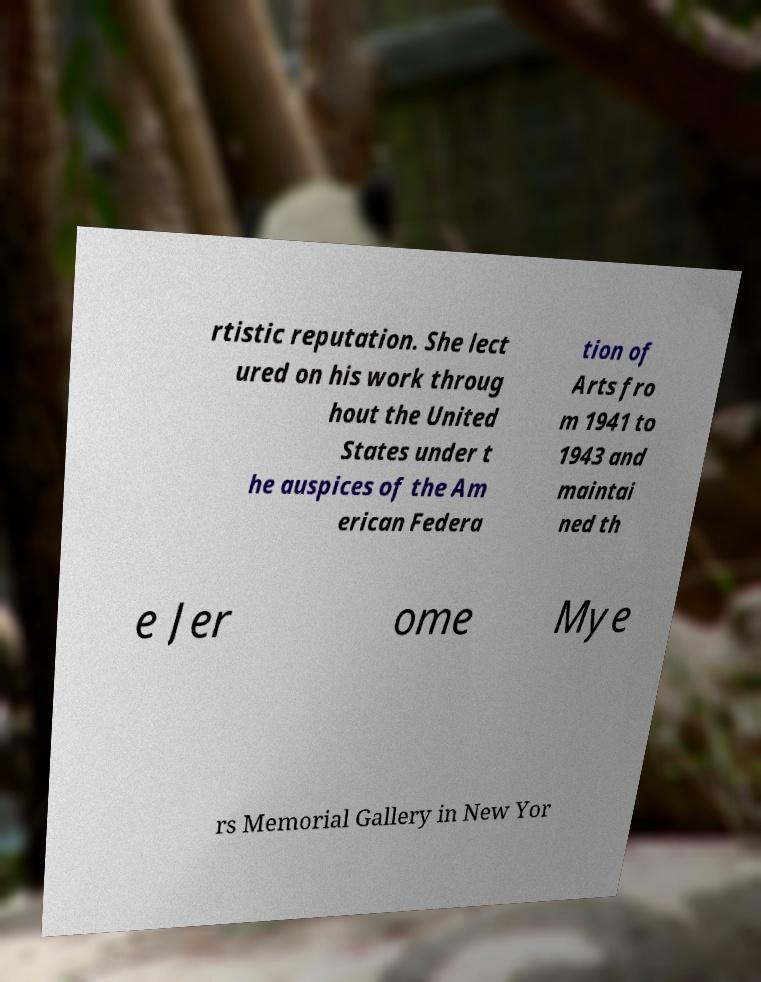What messages or text are displayed in this image? I need them in a readable, typed format. rtistic reputation. She lect ured on his work throug hout the United States under t he auspices of the Am erican Federa tion of Arts fro m 1941 to 1943 and maintai ned th e Jer ome Mye rs Memorial Gallery in New Yor 